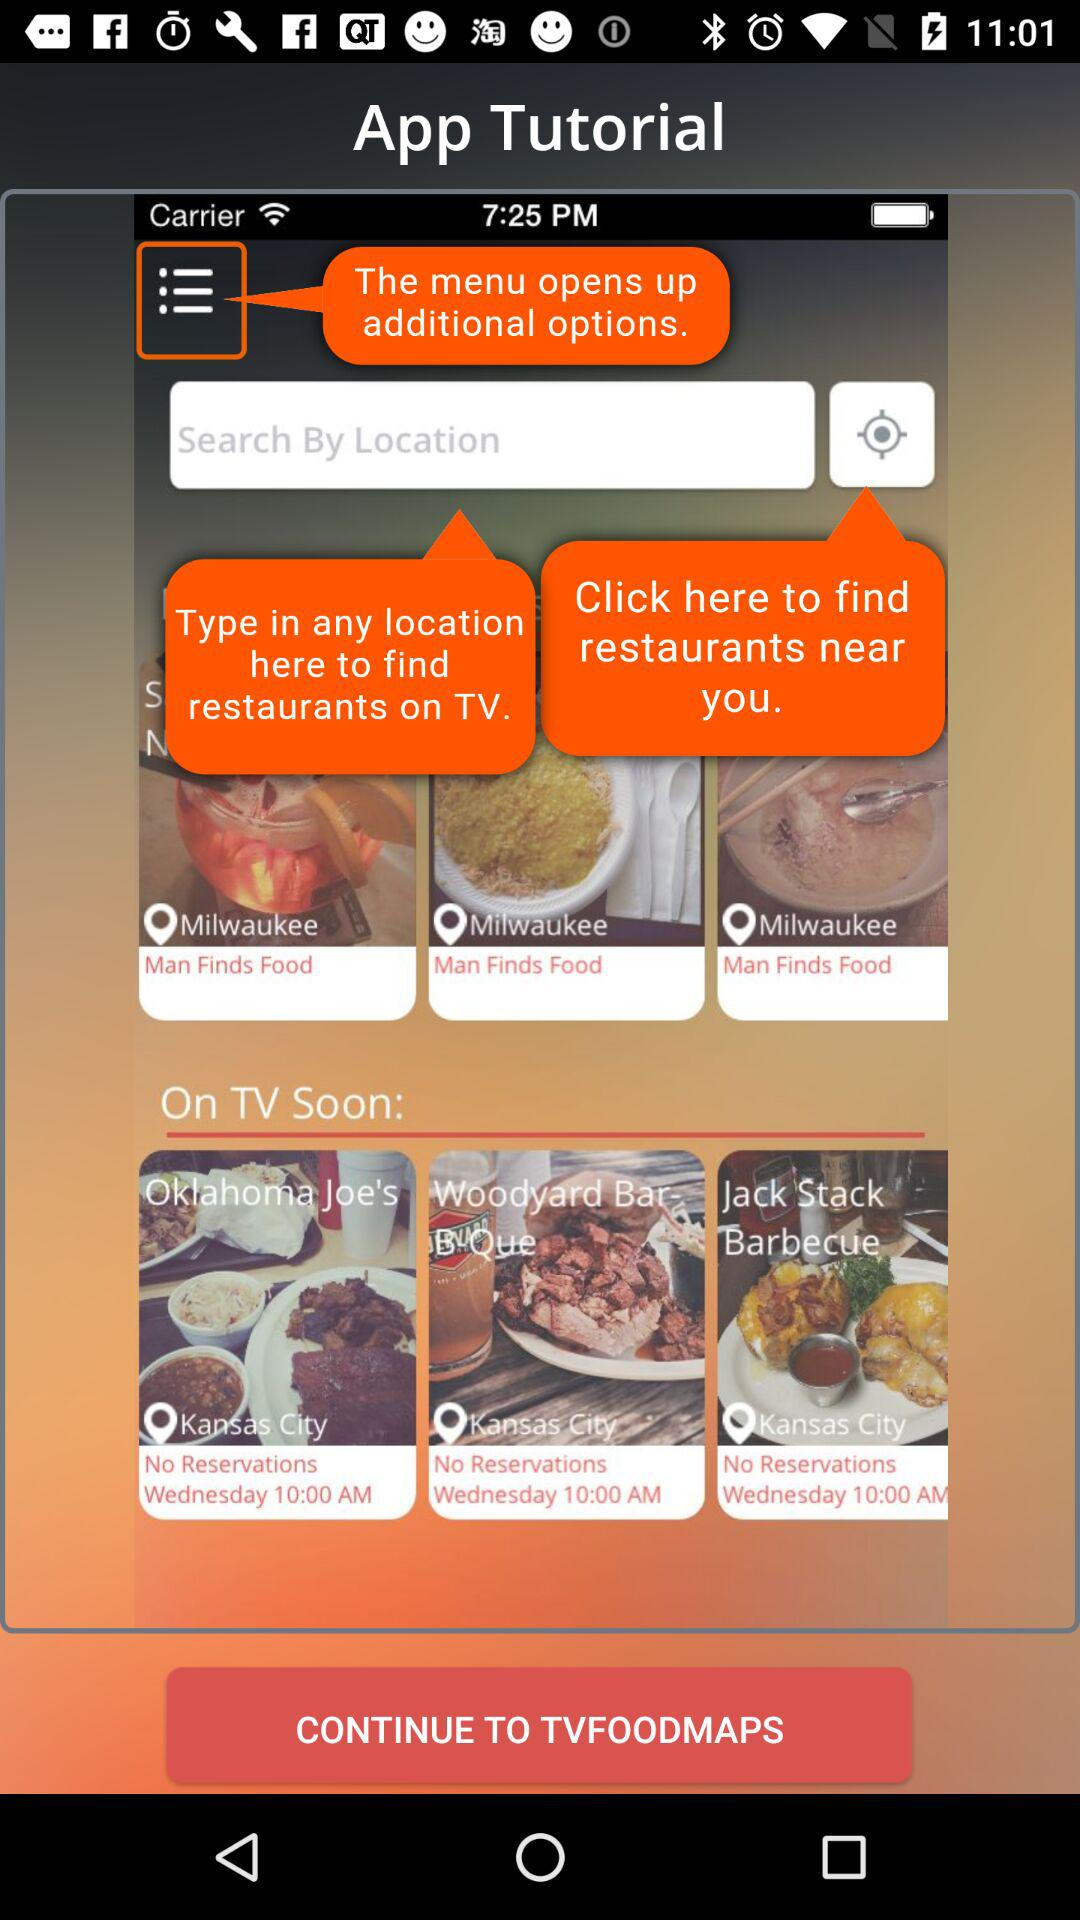On which days are there no reservations at the "Jack Stack Barbecue" restaurant? There are no reservations at the "Jack Stack Barbecue" restaurant on Wednesday. 